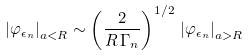Convert formula to latex. <formula><loc_0><loc_0><loc_500><loc_500>\left | \varphi _ { \epsilon _ { n } } \right | _ { a < R } \sim \left ( \frac { 2 } { R \, \Gamma _ { n } } \right ) ^ { 1 / 2 } \, \left | \varphi _ { \epsilon _ { n } } \right | _ { a > R }</formula> 